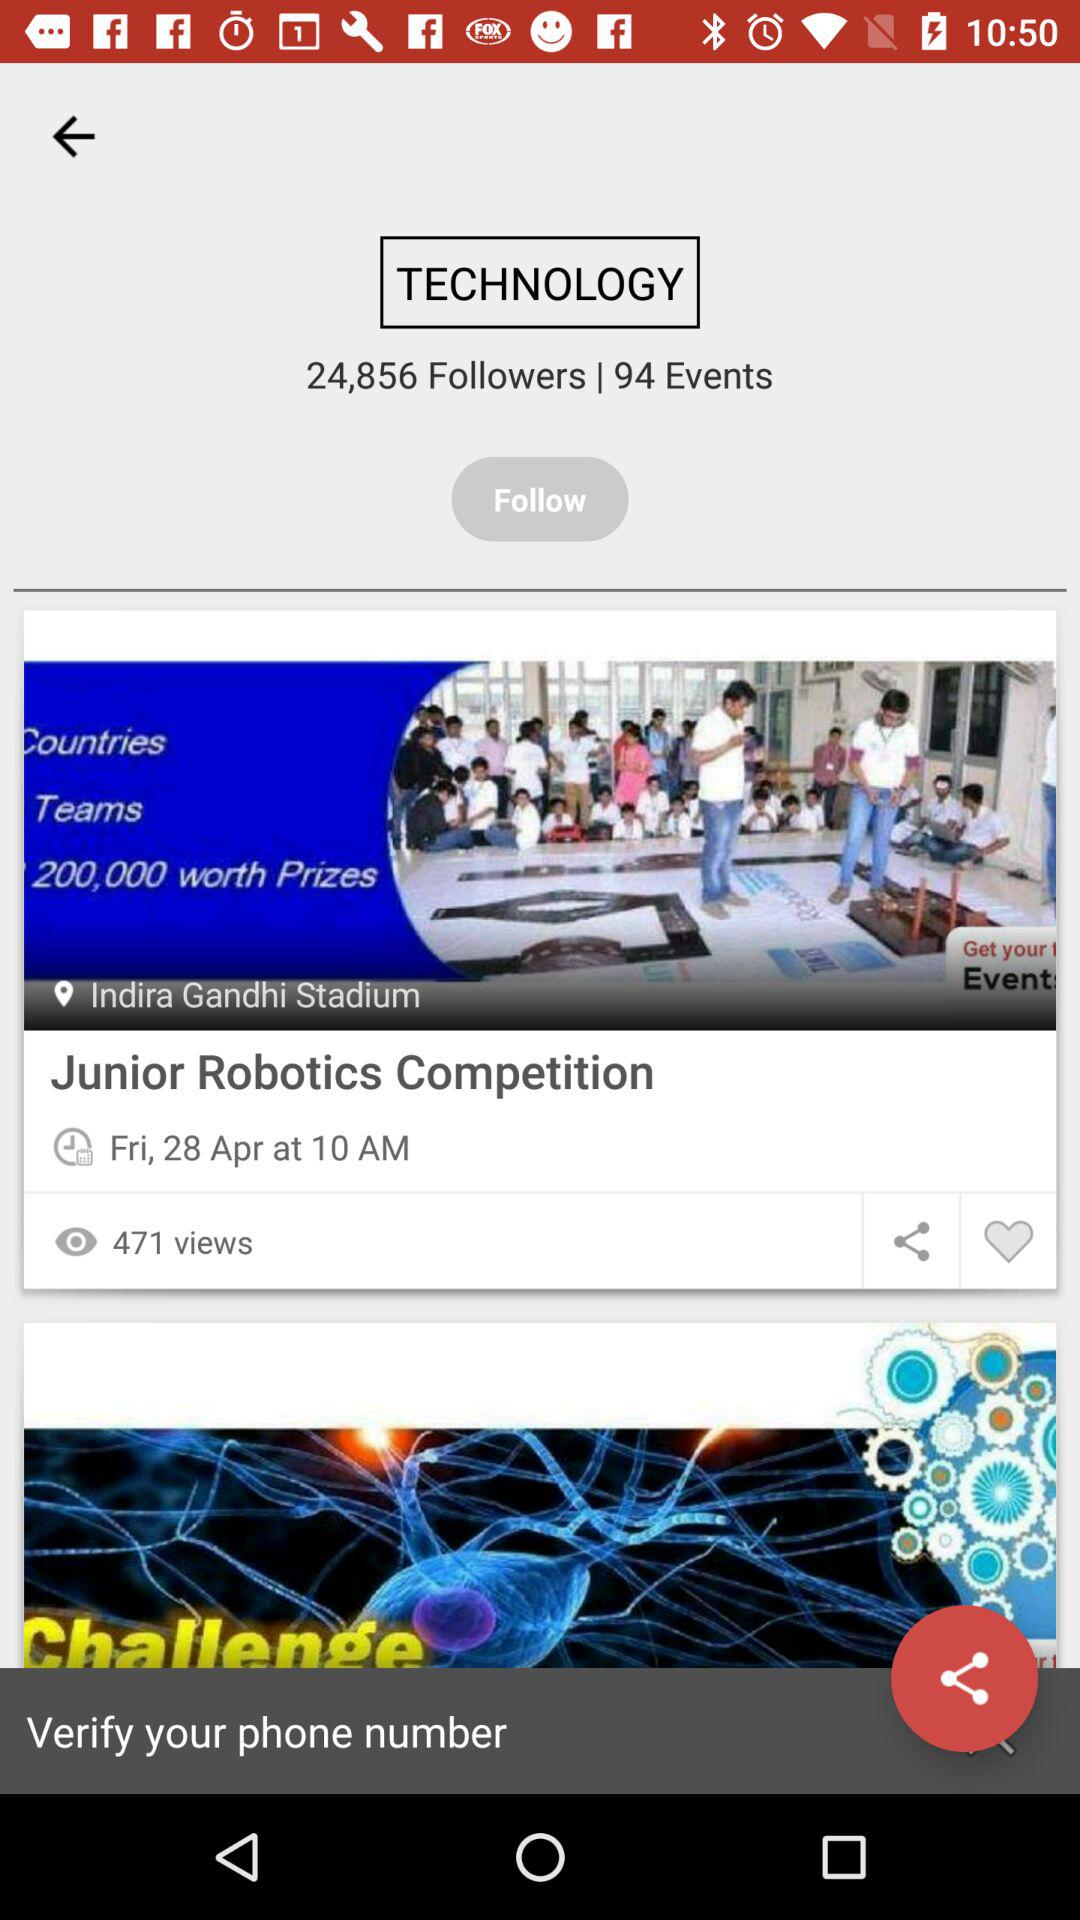What is the total number of views? The total number of views is 471. 